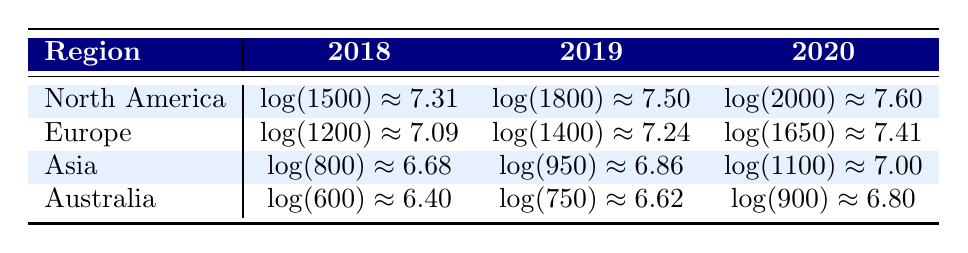What were the flute sales in North America in 2019? The table shows that in North America, the units sold in 2019 is listed as 1800.
Answer: 1800 Which region had the lowest flute sales in 2018? The table indicates that the units sold in 2018 for Australia is 600, which is lower than North America (1500), Europe (1200), and Asia (800).
Answer: Australia What is the difference in flute sales between Europe in 2019 and Asia in 2020? For Europe in 2019, the units sold is 1400; for Asia in 2020, it is 1100. The difference is 1400 - 1100 = 300.
Answer: 300 Is it true that Asia had higher flute sales than Europe in 2019? In 2019, Asia had 950 units sold, while Europe had 1400 units sold. Since 950 is less than 1400, the statement is false.
Answer: No What was the average number of flute sales in Australia over the three years? The total sales in Australia for 2018, 2019, and 2020 are 600 + 750 + 900 = 2250. The average is 2250/3 = 750.
Answer: 750 Which region showed the highest growth in flute sales from 2018 to 2020? Calculating the growth for each region: North America: 2000 - 1500 = 500; Europe: 1650 - 1200 = 450; Asia: 1100 - 800 = 300; Australia: 900 - 600 = 300. North America showed the highest growth of 500 units.
Answer: North America In which year did Australia have the highest logged value of flute sales? Looking at the logged values, Australia had the logged value of approximately 6.80 in 2020. Since that is the highest compared to 6.40 in 2018 and 6.62 in 2019, it is confirmed.
Answer: 2020 Did Europe sell more flutes in 2020 than in 2018? In 2020, Europe sold 1650 flutes, while in 2018, it sold 1200 flutes. Since 1650 is greater than 1200, the statement is true.
Answer: Yes 